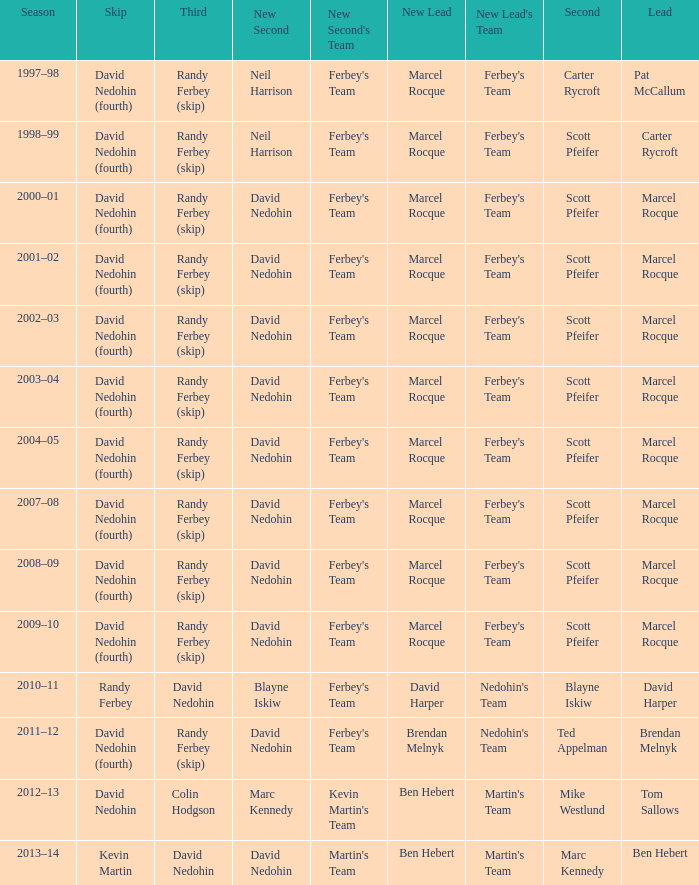Which Season has a Third of colin hodgson? 2012–13. 